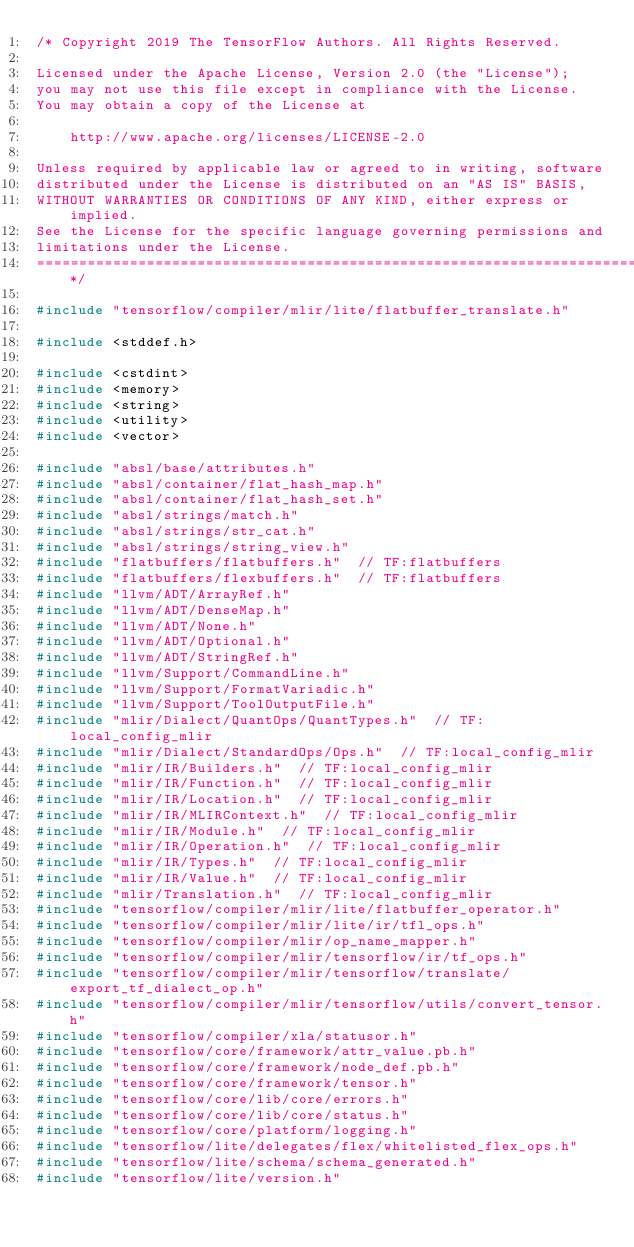Convert code to text. <code><loc_0><loc_0><loc_500><loc_500><_C++_>/* Copyright 2019 The TensorFlow Authors. All Rights Reserved.

Licensed under the Apache License, Version 2.0 (the "License");
you may not use this file except in compliance with the License.
You may obtain a copy of the License at

    http://www.apache.org/licenses/LICENSE-2.0

Unless required by applicable law or agreed to in writing, software
distributed under the License is distributed on an "AS IS" BASIS,
WITHOUT WARRANTIES OR CONDITIONS OF ANY KIND, either express or implied.
See the License for the specific language governing permissions and
limitations under the License.
==============================================================================*/

#include "tensorflow/compiler/mlir/lite/flatbuffer_translate.h"

#include <stddef.h>

#include <cstdint>
#include <memory>
#include <string>
#include <utility>
#include <vector>

#include "absl/base/attributes.h"
#include "absl/container/flat_hash_map.h"
#include "absl/container/flat_hash_set.h"
#include "absl/strings/match.h"
#include "absl/strings/str_cat.h"
#include "absl/strings/string_view.h"
#include "flatbuffers/flatbuffers.h"  // TF:flatbuffers
#include "flatbuffers/flexbuffers.h"  // TF:flatbuffers
#include "llvm/ADT/ArrayRef.h"
#include "llvm/ADT/DenseMap.h"
#include "llvm/ADT/None.h"
#include "llvm/ADT/Optional.h"
#include "llvm/ADT/StringRef.h"
#include "llvm/Support/CommandLine.h"
#include "llvm/Support/FormatVariadic.h"
#include "llvm/Support/ToolOutputFile.h"
#include "mlir/Dialect/QuantOps/QuantTypes.h"  // TF:local_config_mlir
#include "mlir/Dialect/StandardOps/Ops.h"  // TF:local_config_mlir
#include "mlir/IR/Builders.h"  // TF:local_config_mlir
#include "mlir/IR/Function.h"  // TF:local_config_mlir
#include "mlir/IR/Location.h"  // TF:local_config_mlir
#include "mlir/IR/MLIRContext.h"  // TF:local_config_mlir
#include "mlir/IR/Module.h"  // TF:local_config_mlir
#include "mlir/IR/Operation.h"  // TF:local_config_mlir
#include "mlir/IR/Types.h"  // TF:local_config_mlir
#include "mlir/IR/Value.h"  // TF:local_config_mlir
#include "mlir/Translation.h"  // TF:local_config_mlir
#include "tensorflow/compiler/mlir/lite/flatbuffer_operator.h"
#include "tensorflow/compiler/mlir/lite/ir/tfl_ops.h"
#include "tensorflow/compiler/mlir/op_name_mapper.h"
#include "tensorflow/compiler/mlir/tensorflow/ir/tf_ops.h"
#include "tensorflow/compiler/mlir/tensorflow/translate/export_tf_dialect_op.h"
#include "tensorflow/compiler/mlir/tensorflow/utils/convert_tensor.h"
#include "tensorflow/compiler/xla/statusor.h"
#include "tensorflow/core/framework/attr_value.pb.h"
#include "tensorflow/core/framework/node_def.pb.h"
#include "tensorflow/core/framework/tensor.h"
#include "tensorflow/core/lib/core/errors.h"
#include "tensorflow/core/lib/core/status.h"
#include "tensorflow/core/platform/logging.h"
#include "tensorflow/lite/delegates/flex/whitelisted_flex_ops.h"
#include "tensorflow/lite/schema/schema_generated.h"
#include "tensorflow/lite/version.h"
</code> 